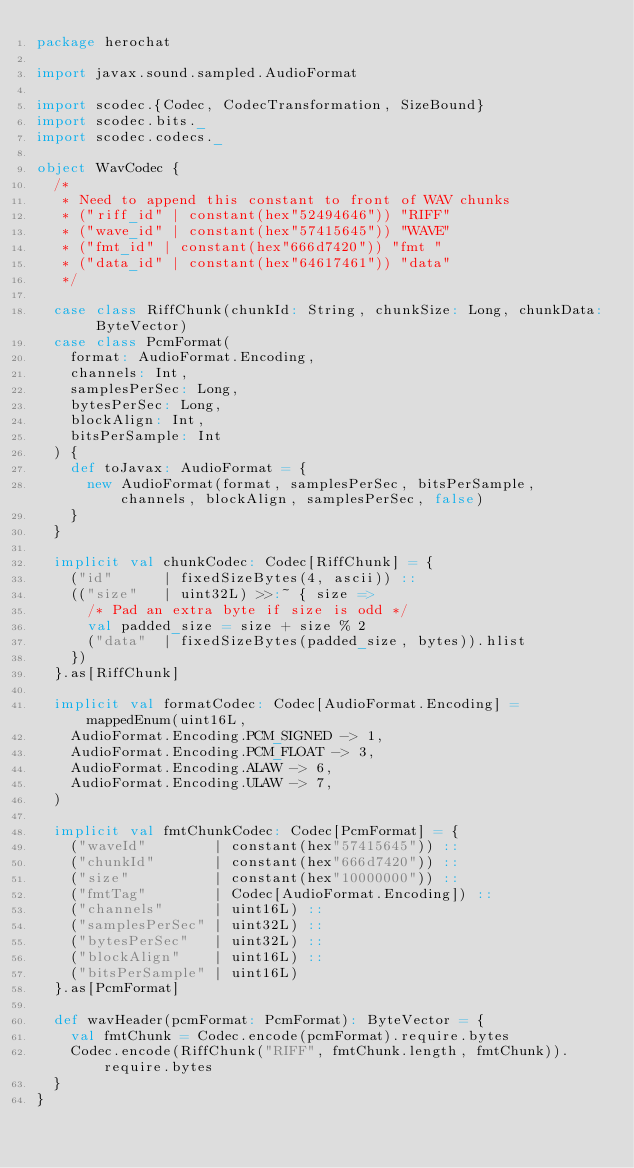<code> <loc_0><loc_0><loc_500><loc_500><_Scala_>package herochat

import javax.sound.sampled.AudioFormat

import scodec.{Codec, CodecTransformation, SizeBound}
import scodec.bits._
import scodec.codecs._

object WavCodec {
  /*
   * Need to append this constant to front of WAV chunks
   * ("riff_id" | constant(hex"52494646")) "RIFF"
   * ("wave_id" | constant(hex"57415645")) "WAVE"
   * ("fmt_id" | constant(hex"666d7420")) "fmt "
   * ("data_id" | constant(hex"64617461")) "data"
   */

  case class RiffChunk(chunkId: String, chunkSize: Long, chunkData: ByteVector)
  case class PcmFormat(
    format: AudioFormat.Encoding,
    channels: Int,
    samplesPerSec: Long,
    bytesPerSec: Long,
    blockAlign: Int,
    bitsPerSample: Int
  ) {
    def toJavax: AudioFormat = {
      new AudioFormat(format, samplesPerSec, bitsPerSample, channels, blockAlign, samplesPerSec, false)
    }
  }

  implicit val chunkCodec: Codec[RiffChunk] = {
    ("id"      | fixedSizeBytes(4, ascii)) ::
    (("size"   | uint32L) >>:~ { size =>
      /* Pad an extra byte if size is odd */
      val padded_size = size + size % 2
      ("data"  | fixedSizeBytes(padded_size, bytes)).hlist
    })
  }.as[RiffChunk]

  implicit val formatCodec: Codec[AudioFormat.Encoding] = mappedEnum(uint16L,
    AudioFormat.Encoding.PCM_SIGNED -> 1,
    AudioFormat.Encoding.PCM_FLOAT -> 3,
    AudioFormat.Encoding.ALAW -> 6,
    AudioFormat.Encoding.ULAW -> 7,
  )

  implicit val fmtChunkCodec: Codec[PcmFormat] = {
    ("waveId"        | constant(hex"57415645")) ::
    ("chunkId"       | constant(hex"666d7420")) ::
    ("size"          | constant(hex"10000000")) ::
    ("fmtTag"        | Codec[AudioFormat.Encoding]) ::
    ("channels"      | uint16L) ::
    ("samplesPerSec" | uint32L) ::
    ("bytesPerSec"   | uint32L) ::
    ("blockAlign"    | uint16L) ::
    ("bitsPerSample" | uint16L)
  }.as[PcmFormat]

  def wavHeader(pcmFormat: PcmFormat): ByteVector = {
    val fmtChunk = Codec.encode(pcmFormat).require.bytes
    Codec.encode(RiffChunk("RIFF", fmtChunk.length, fmtChunk)).require.bytes
  }
}
</code> 